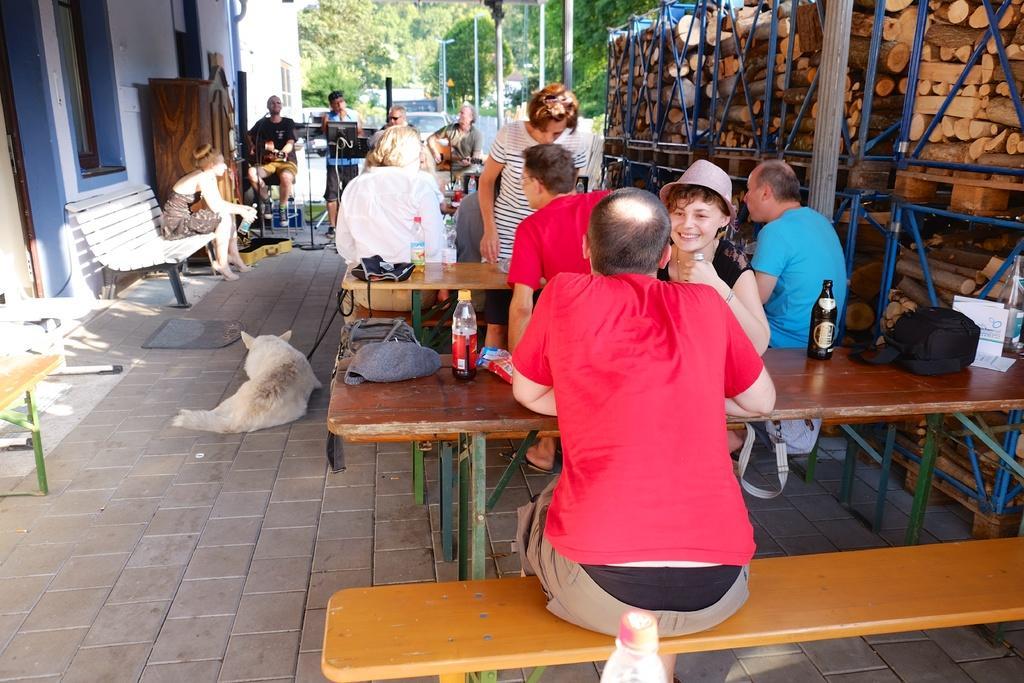How would you summarize this image in a sentence or two? In this image there are group of people sitting on the bench. On the table there is bottle and a bag. On the floor the dog is lying. At the background we can see building and trees. 